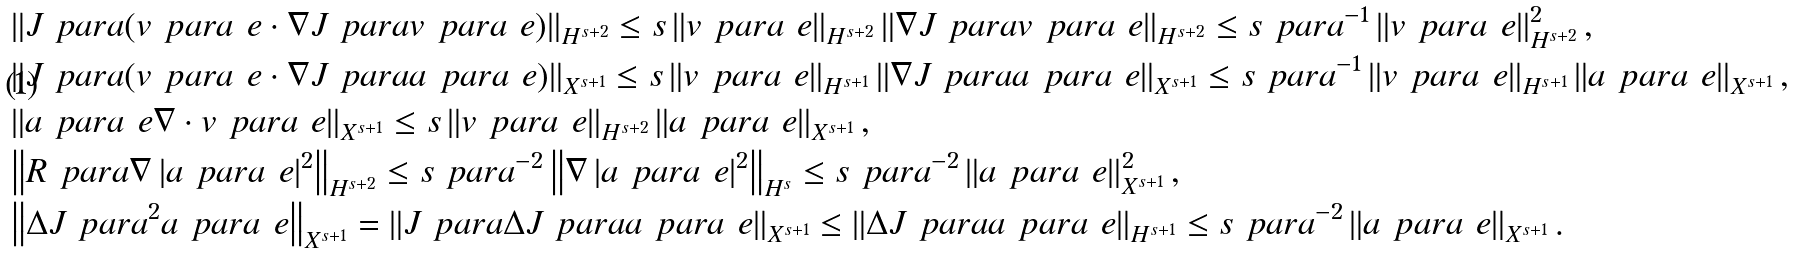<formula> <loc_0><loc_0><loc_500><loc_500>& \left \| J _ { \ } p a r a ( v _ { \ } p a r a ^ { \ } e \cdot \nabla J _ { \ } p a r a v _ { \ } p a r a ^ { \ } e ) \right \| _ { H ^ { s + 2 } } \leq s \left \| v _ { \ } p a r a ^ { \ } e \right \| _ { H ^ { s + 2 } } \left \| \nabla J _ { \ } p a r a v _ { \ } p a r a ^ { \ } e \right \| _ { H ^ { s + 2 } } \leq s \ p a r a ^ { - 1 } \left \| v _ { \ } p a r a ^ { \ } e \right \| _ { H ^ { s + 2 } } ^ { 2 } , \\ & \left \| J _ { \ } p a r a ( v _ { \ } p a r a ^ { \ } e \cdot \nabla J _ { \ } p a r a a _ { \ } p a r a ^ { \ } e ) \right \| _ { X ^ { s + 1 } } \leq s \left \| v _ { \ } p a r a ^ { \ } e \right \| _ { H ^ { s + 1 } } \left \| \nabla J _ { \ } p a r a a _ { \ } p a r a ^ { \ } e \right \| _ { X ^ { s + 1 } } \leq s \ p a r a ^ { - 1 } \left \| v _ { \ } p a r a ^ { \ } e \right \| _ { H ^ { s + 1 } } \left \| a _ { \ } p a r a ^ { \ } e \right \| _ { X ^ { s + 1 } } , \\ & \left \| a _ { \ } p a r a ^ { \ } e \nabla \cdot v _ { \ } p a r a ^ { \ } e \right \| _ { X ^ { s + 1 } } \leq s \left \| v _ { \ } p a r a ^ { \ } e \right \| _ { H ^ { s + 2 } } \left \| a _ { \ } p a r a ^ { \ } e \right \| _ { X ^ { s + 1 } } , \\ & \left \| R _ { \ } p a r a \nabla \left | a _ { \ } p a r a ^ { \ } e \right | ^ { 2 } \right \| _ { H ^ { s + 2 } } \leq s \ p a r a ^ { - 2 } \left \| \nabla \left | a _ { \ } p a r a ^ { \ } e \right | ^ { 2 } \right \| _ { H ^ { s } } \leq s \ p a r a ^ { - 2 } \left \| a _ { \ } p a r a ^ { \ } e \right \| _ { X ^ { s + 1 } } ^ { 2 } , \\ & \left \| \Delta J _ { \ } p a r a ^ { 2 } a _ { \ } p a r a ^ { \ } e \right \| _ { X ^ { s + 1 } } = \left \| J _ { \ } p a r a \Delta J _ { \ } p a r a a _ { \ } p a r a ^ { \ } e \right \| _ { X ^ { s + 1 } } \leq \left \| \Delta J _ { \ } p a r a a _ { \ } p a r a ^ { \ } e \right \| _ { H ^ { s + 1 } } \leq s \ p a r a ^ { - 2 } \left \| a _ { \ } p a r a ^ { \ } e \right \| _ { X ^ { s + 1 } } .</formula> 